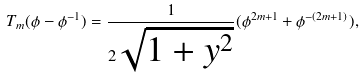Convert formula to latex. <formula><loc_0><loc_0><loc_500><loc_500>T _ { m } ( \phi - \phi ^ { - 1 } ) = \frac { 1 } { 2 \sqrt { 1 + y ^ { 2 } } } ( \phi ^ { 2 m + 1 } + \phi ^ { - ( 2 m + 1 ) } ) ,</formula> 